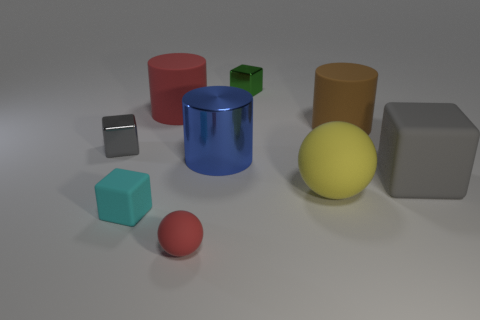The matte object that is the same color as the small ball is what shape? The matte object sharing the same vivid blue color as the small ball on the left is indeed a cylinder. This cylindrical object stands out due to its reflective surface and distinct color that matches the ball. 